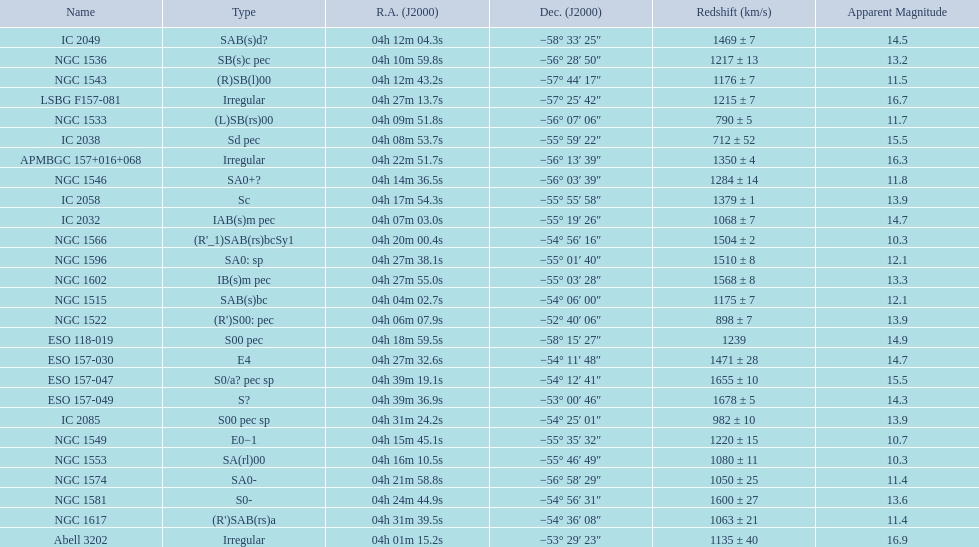What count of "unusual" forms are there? 3. 